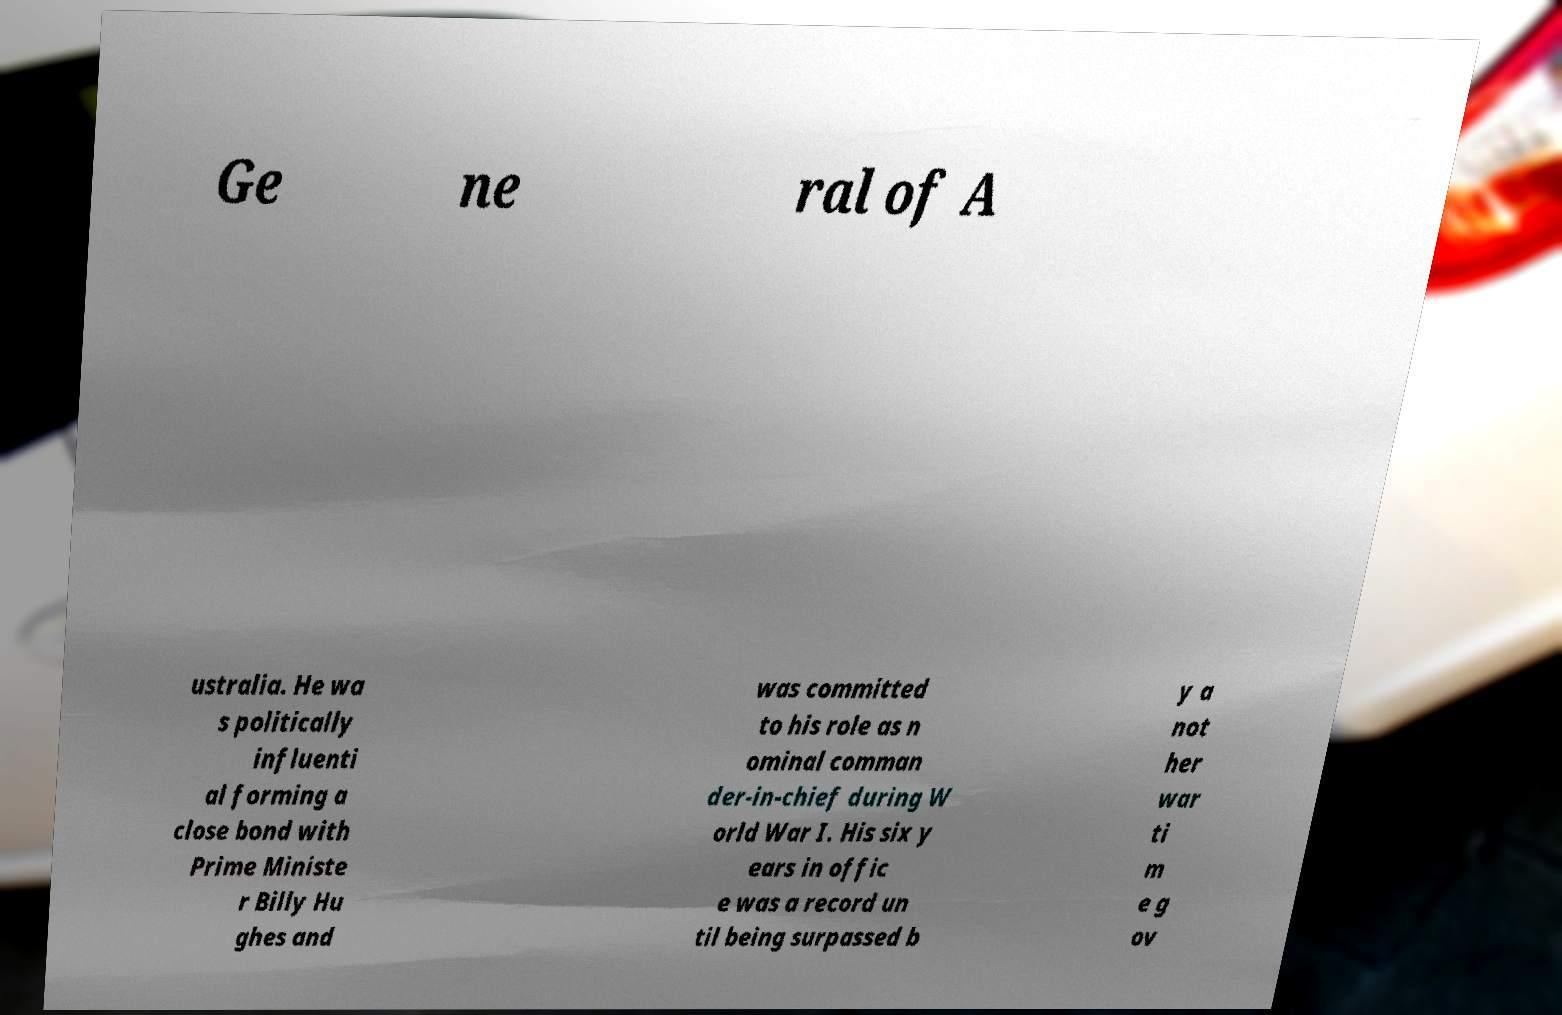I need the written content from this picture converted into text. Can you do that? Ge ne ral of A ustralia. He wa s politically influenti al forming a close bond with Prime Ministe r Billy Hu ghes and was committed to his role as n ominal comman der-in-chief during W orld War I. His six y ears in offic e was a record un til being surpassed b y a not her war ti m e g ov 